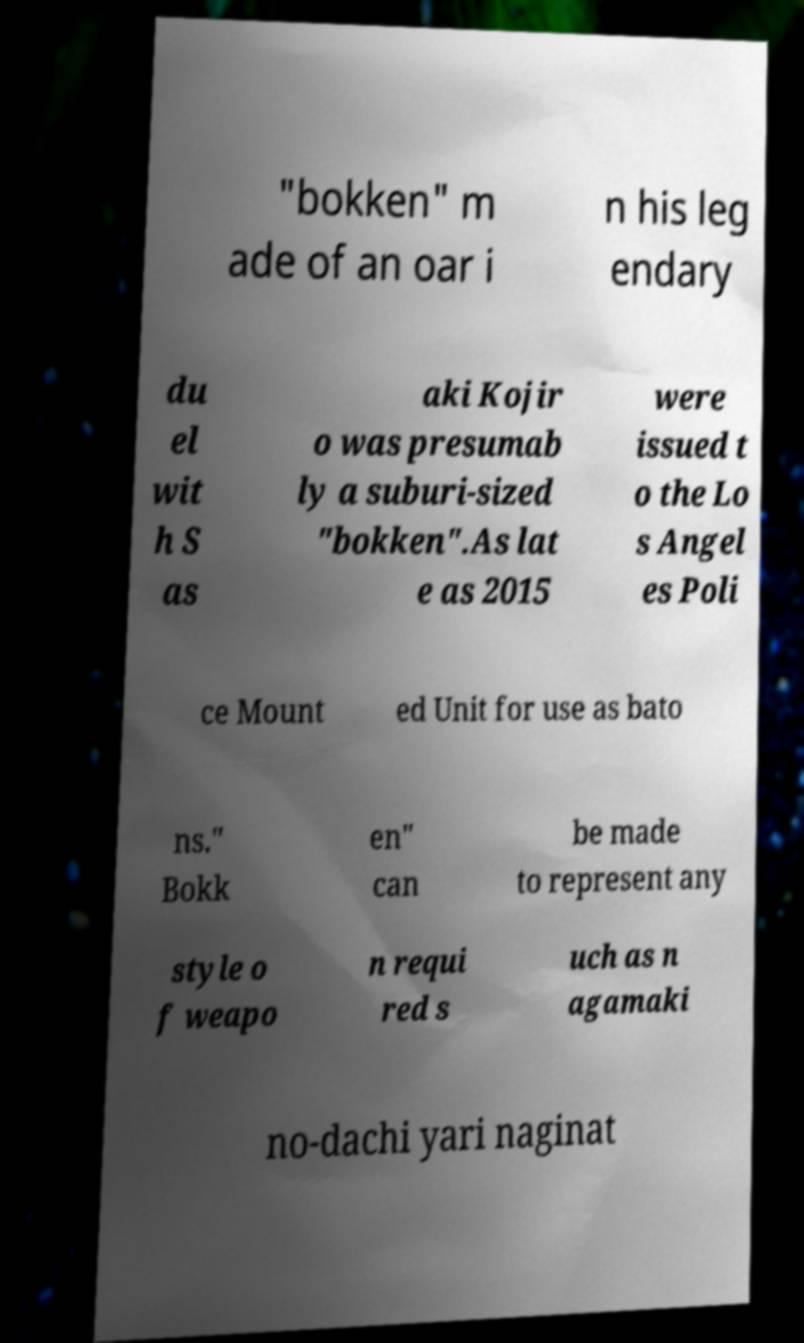For documentation purposes, I need the text within this image transcribed. Could you provide that? "bokken" m ade of an oar i n his leg endary du el wit h S as aki Kojir o was presumab ly a suburi-sized "bokken".As lat e as 2015 were issued t o the Lo s Angel es Poli ce Mount ed Unit for use as bato ns." Bokk en" can be made to represent any style o f weapo n requi red s uch as n agamaki no-dachi yari naginat 